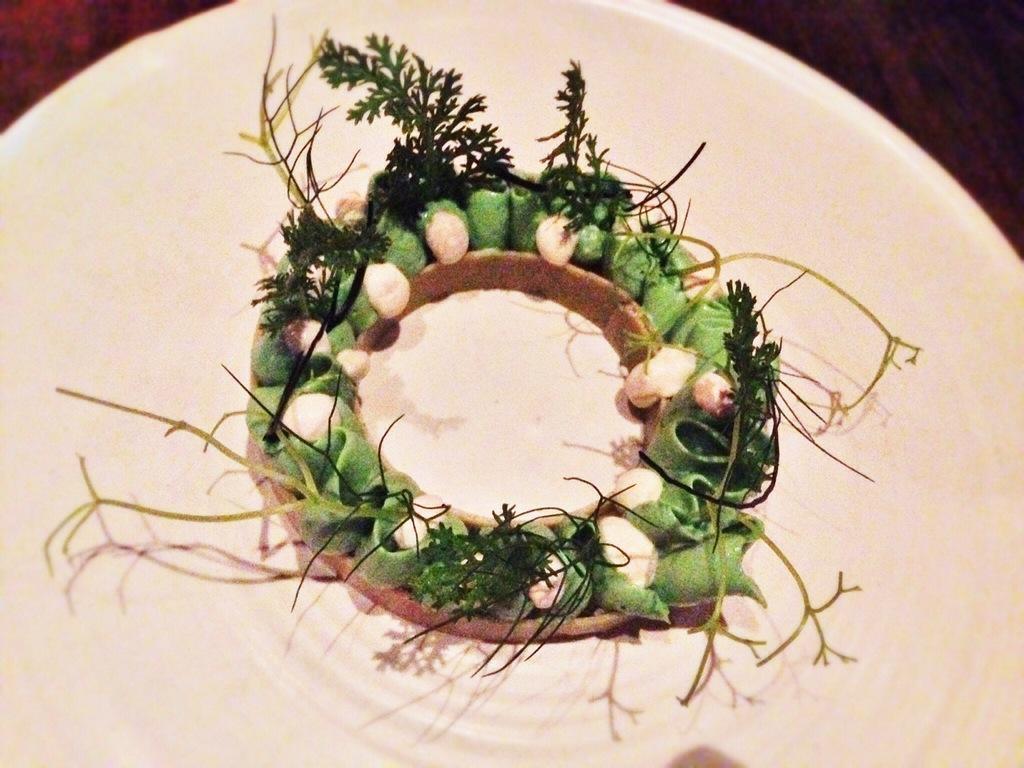In one or two sentences, can you explain what this image depicts? In this image there is one plate, in the plate there are some seeds and food items. At the top of the image it looks like a table. 